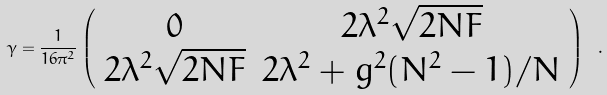<formula> <loc_0><loc_0><loc_500><loc_500>\gamma = \frac { 1 } { 1 6 \pi ^ { 2 } } \left ( \begin{array} { c c } 0 & 2 \lambda ^ { 2 } \sqrt { 2 N F } \\ 2 \lambda ^ { 2 } \sqrt { 2 N F } & 2 \lambda ^ { 2 } + g ^ { 2 } ( N ^ { 2 } - 1 ) / N \end{array} \right ) \ .</formula> 